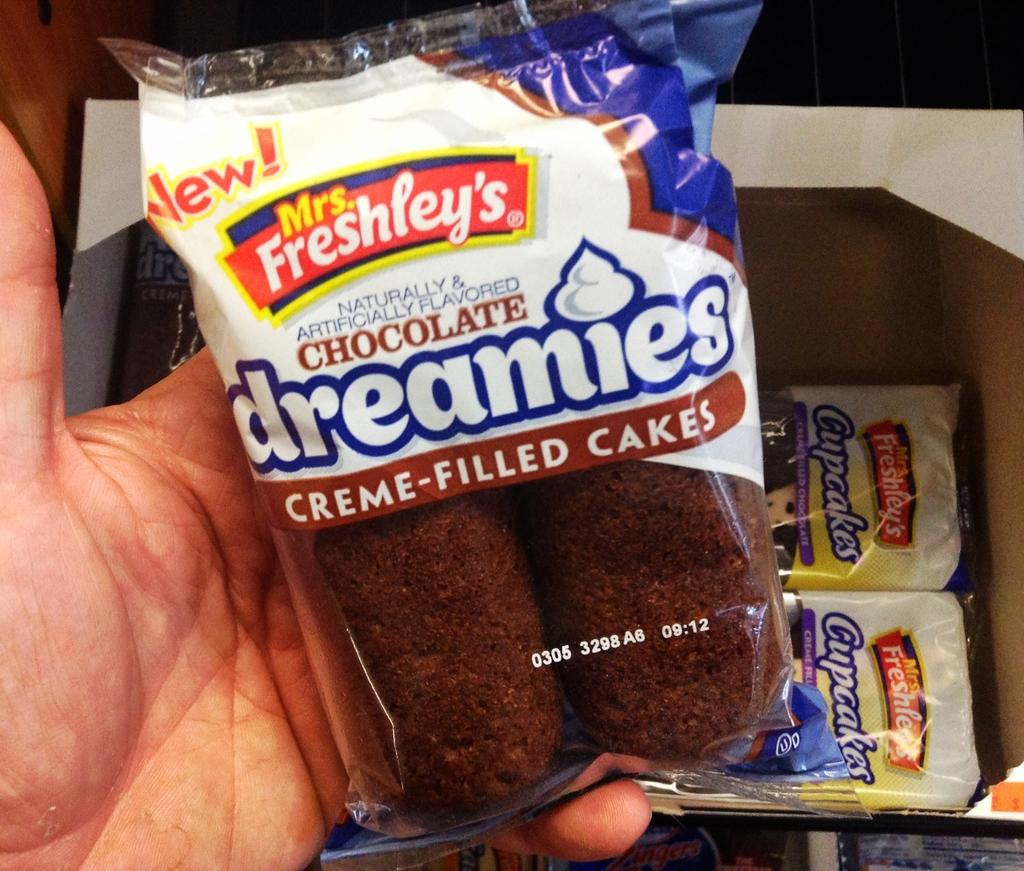<image>
Write a terse but informative summary of the picture. A hand holding a pack of chocolate creme-filled cakes. 